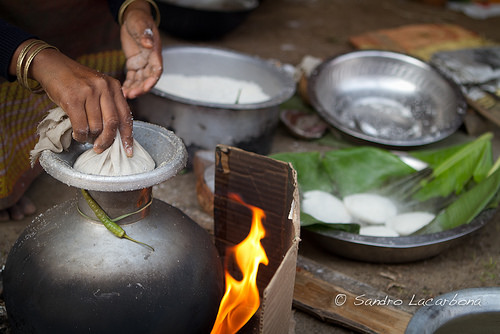<image>
Is the vase to the right of the fire? No. The vase is not to the right of the fire. The horizontal positioning shows a different relationship. 